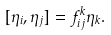Convert formula to latex. <formula><loc_0><loc_0><loc_500><loc_500>[ \eta _ { i } , \eta _ { j } ] = f _ { i j } ^ { k } \eta _ { k } .</formula> 